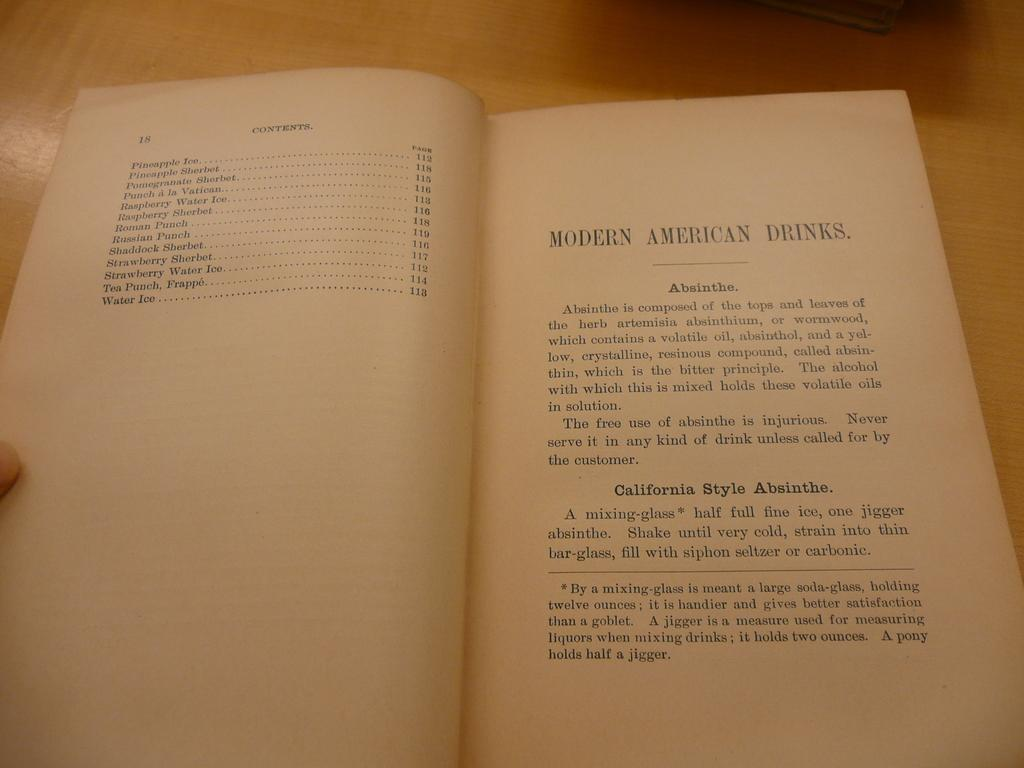<image>
Write a terse but informative summary of the picture. Book open on a page titled "Modern American Drinks". 